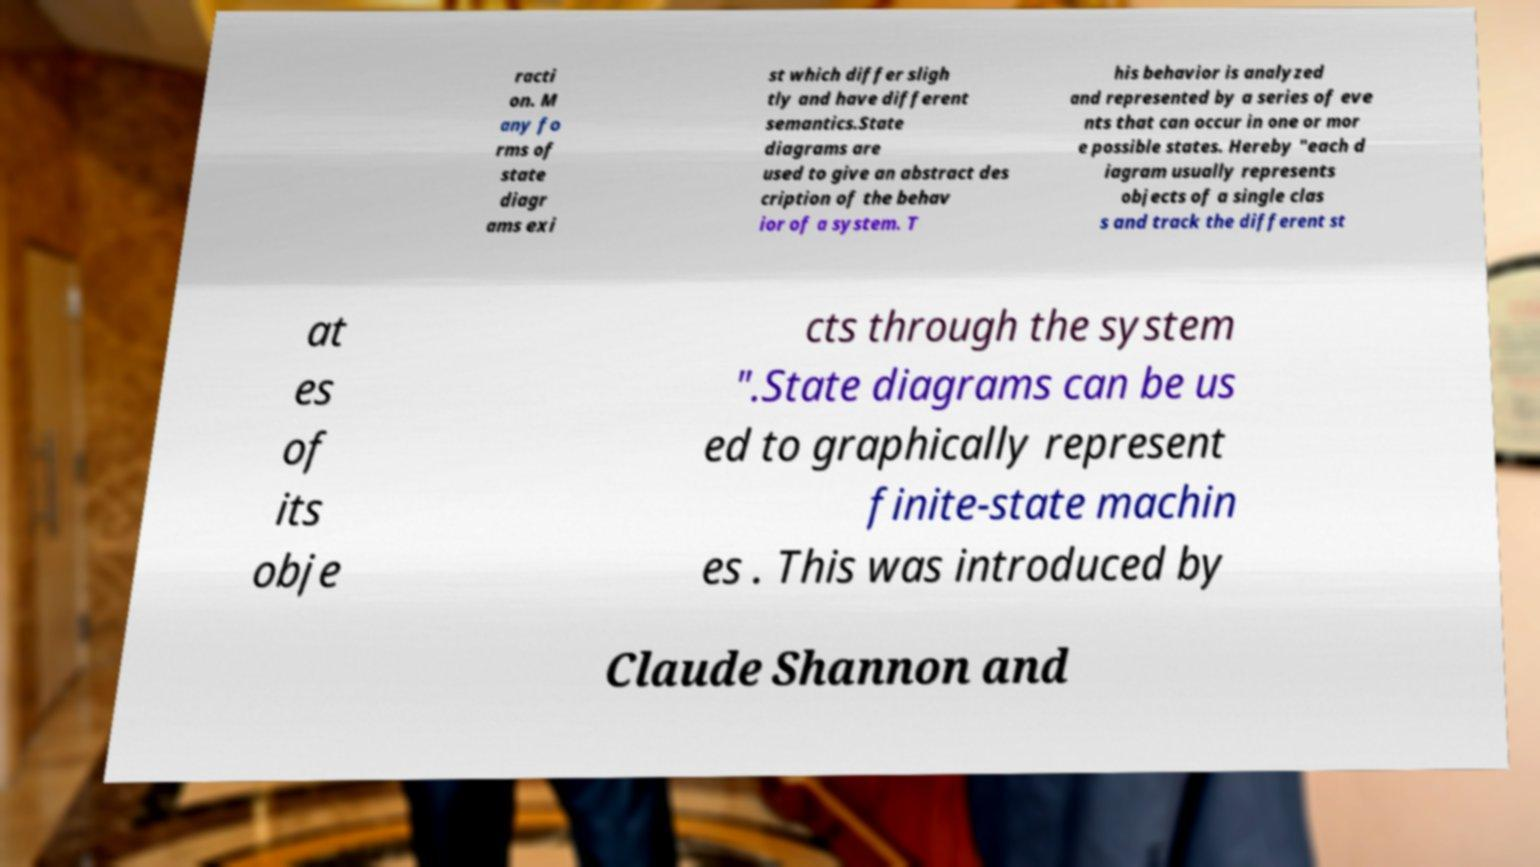What messages or text are displayed in this image? I need them in a readable, typed format. racti on. M any fo rms of state diagr ams exi st which differ sligh tly and have different semantics.State diagrams are used to give an abstract des cription of the behav ior of a system. T his behavior is analyzed and represented by a series of eve nts that can occur in one or mor e possible states. Hereby "each d iagram usually represents objects of a single clas s and track the different st at es of its obje cts through the system ".State diagrams can be us ed to graphically represent finite-state machin es . This was introduced by Claude Shannon and 